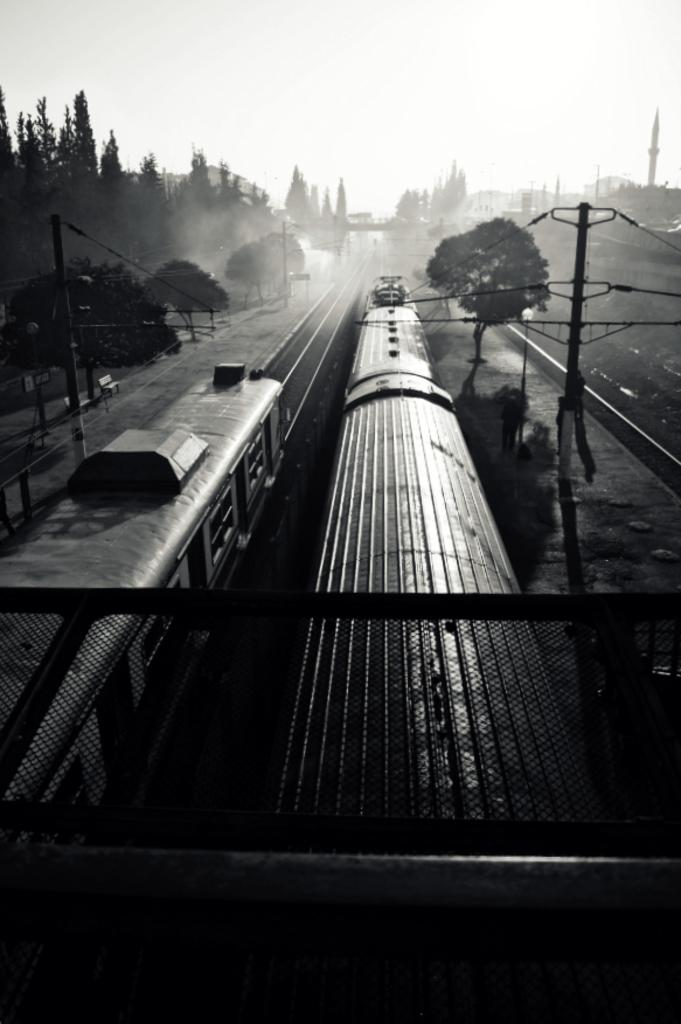What is the main subject of the image? The main subject of the image is a train passing on the track. What can be seen in the background of the image? There are trees visible in the image. What else is present in the image besides the train and trees? There are electric poles in the image. How would you describe the weather based on the image? The sky is clear in the image, suggesting good weather. Can you see the children playing with the wave in the image? There is no wave or children playing in the image; it features a train passing on the track, trees, electric poles, and a clear sky. 